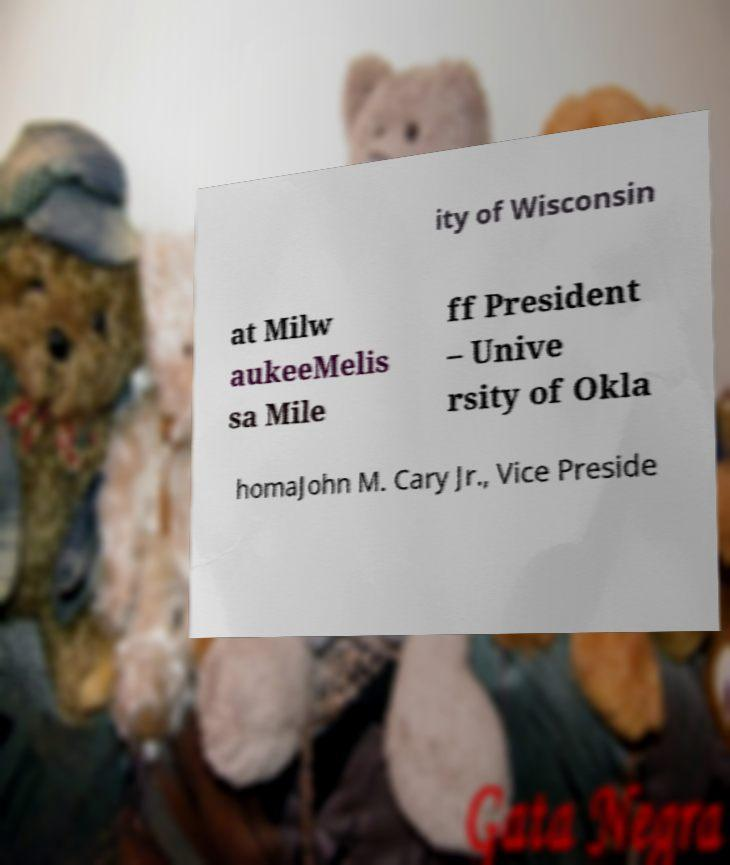There's text embedded in this image that I need extracted. Can you transcribe it verbatim? ity of Wisconsin at Milw aukeeMelis sa Mile ff President – Unive rsity of Okla homaJohn M. Cary Jr., Vice Preside 